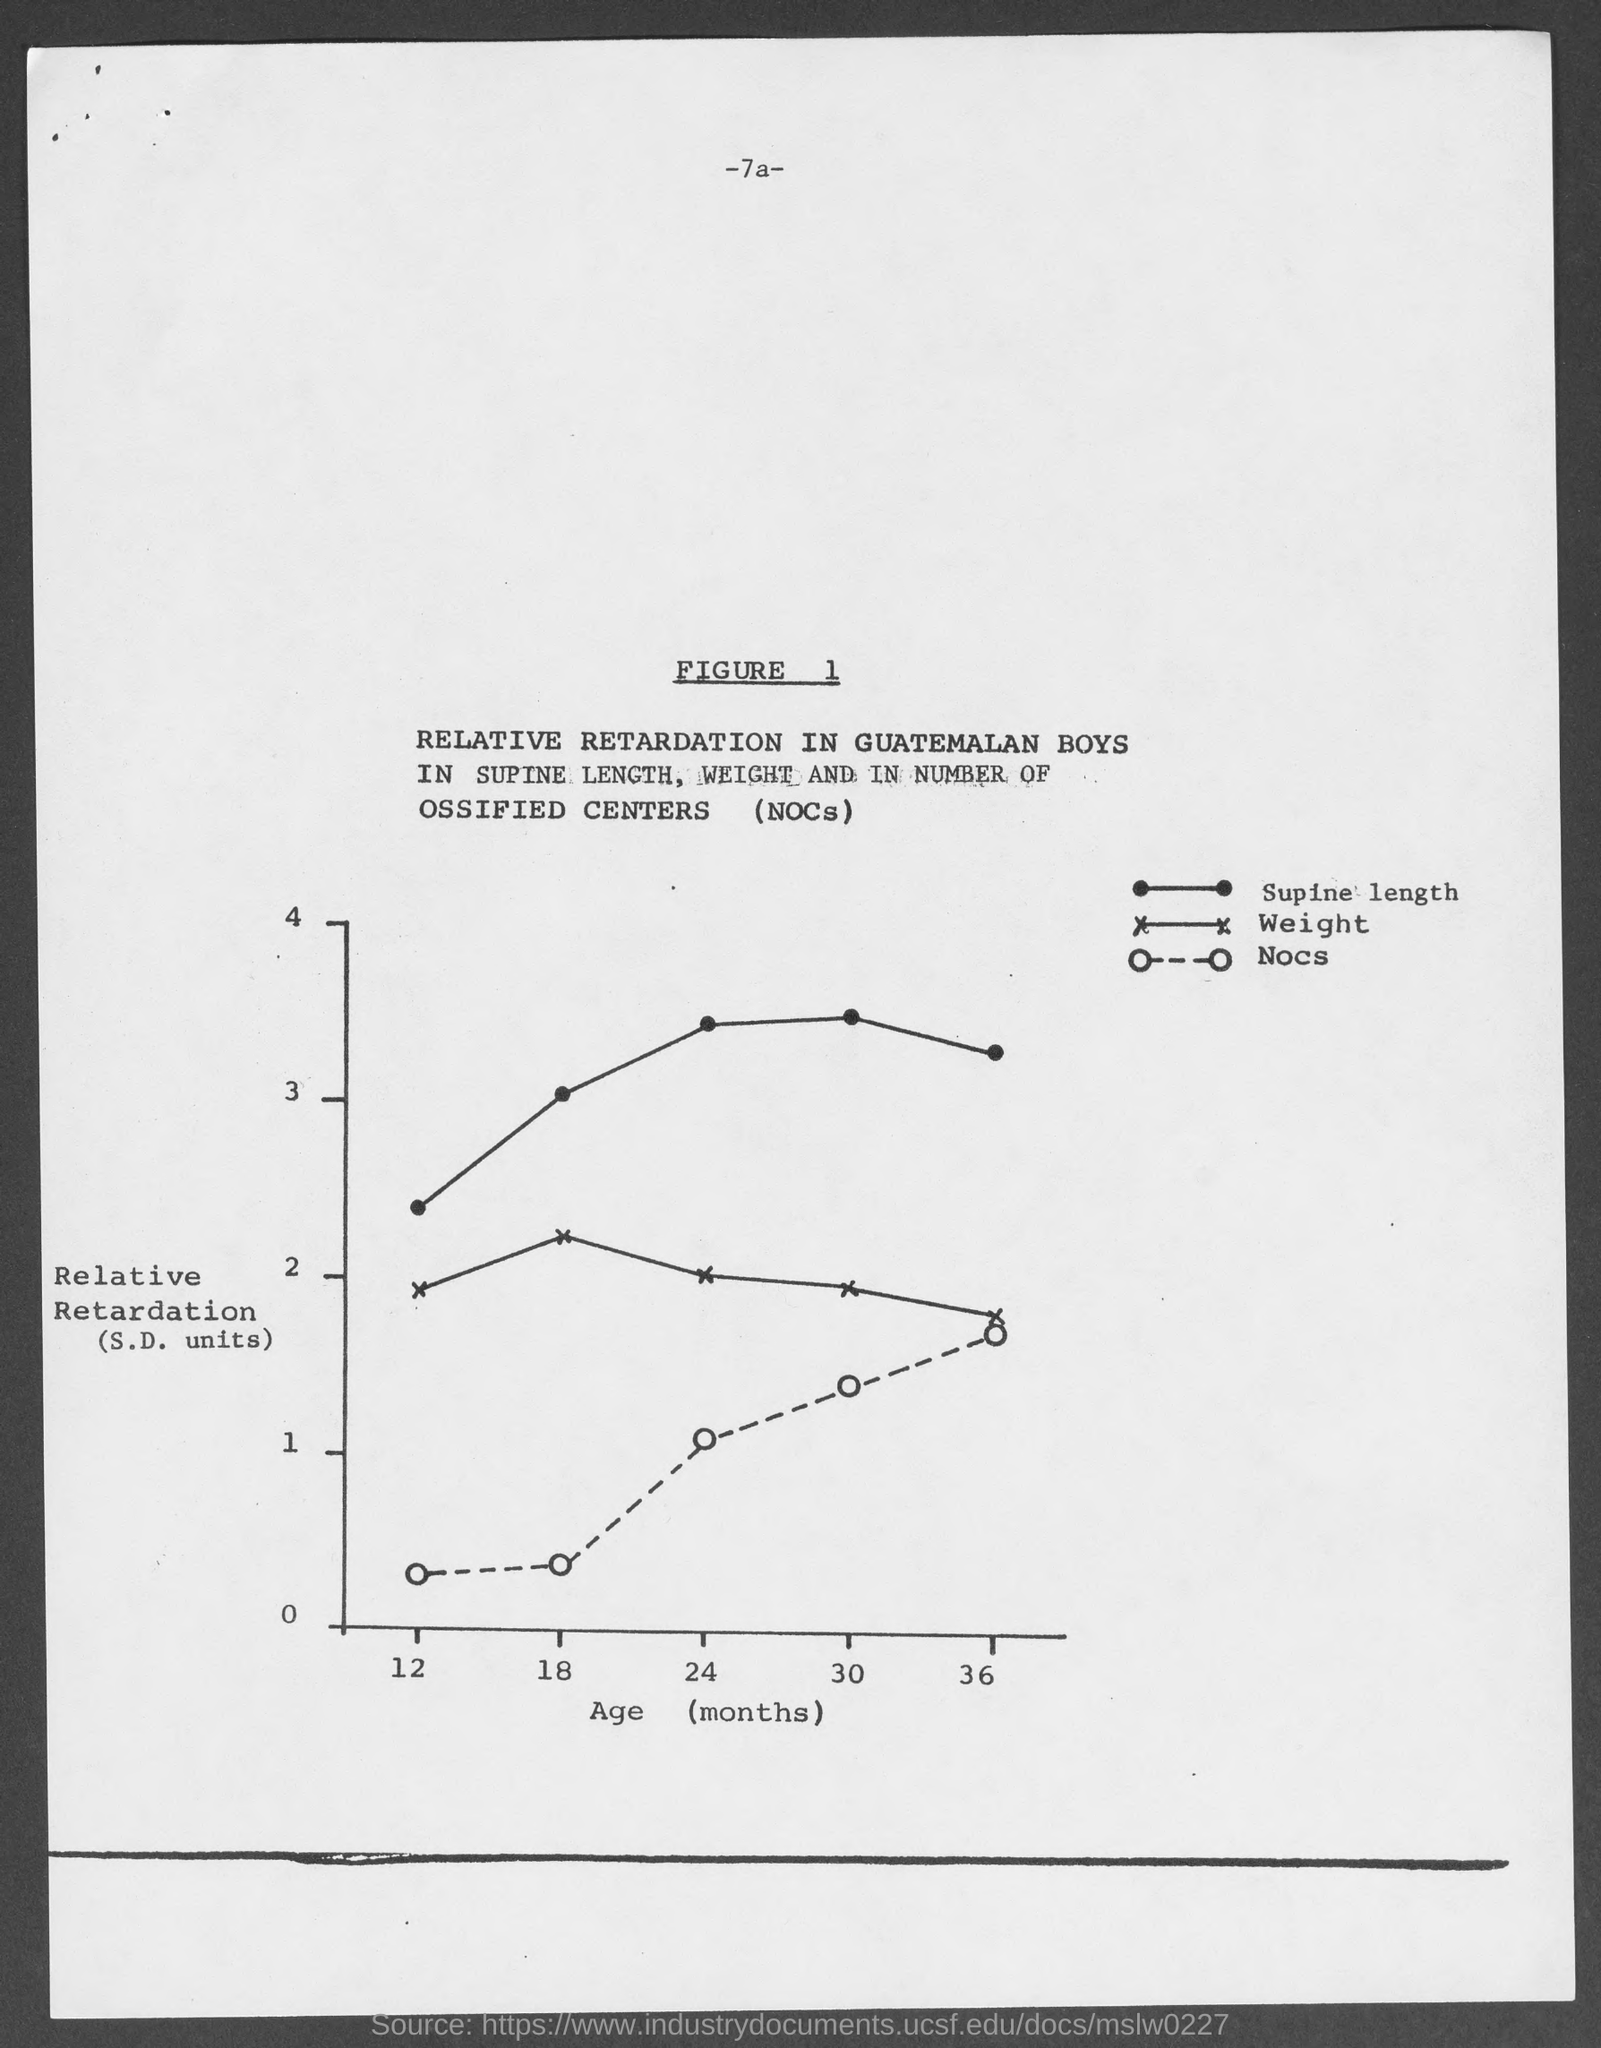Identify some key points in this picture. The dotted line in the graph indicates a relationship between two variables, which is denoted by the symbol "NOCS. 